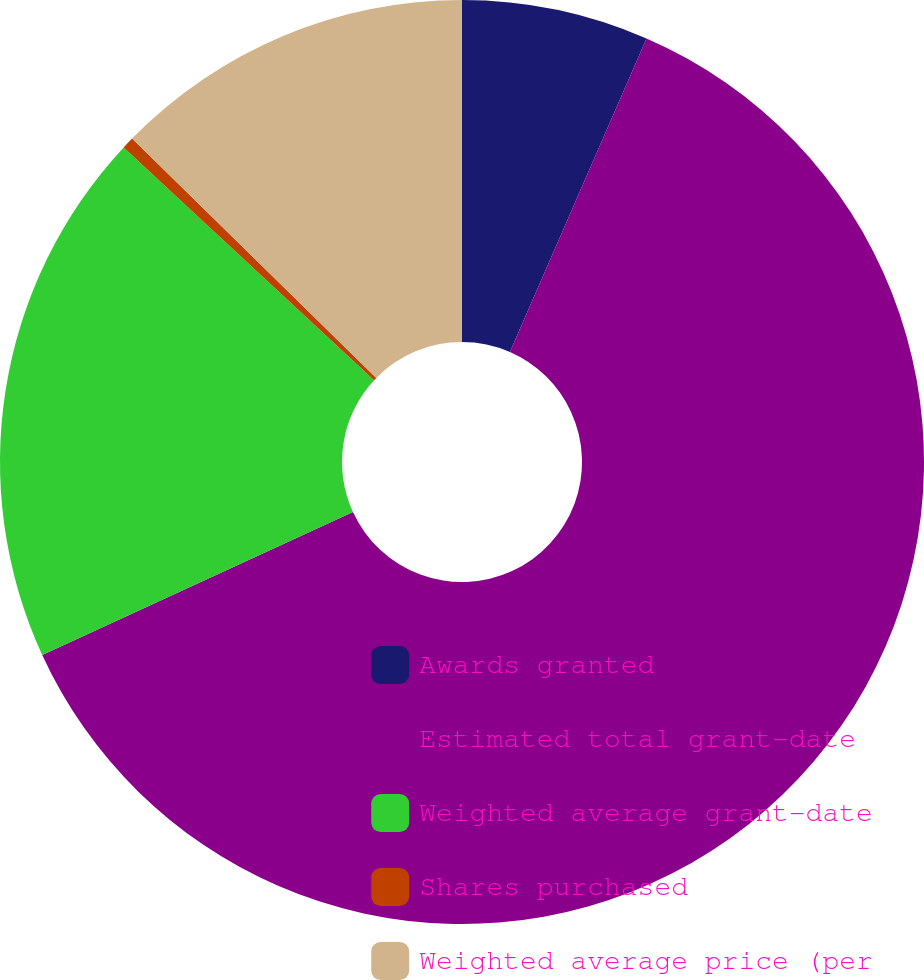<chart> <loc_0><loc_0><loc_500><loc_500><pie_chart><fcel>Awards granted<fcel>Estimated total grant-date<fcel>Weighted average grant-date<fcel>Shares purchased<fcel>Weighted average price (per<nl><fcel>6.54%<fcel>61.61%<fcel>18.78%<fcel>0.42%<fcel>12.66%<nl></chart> 